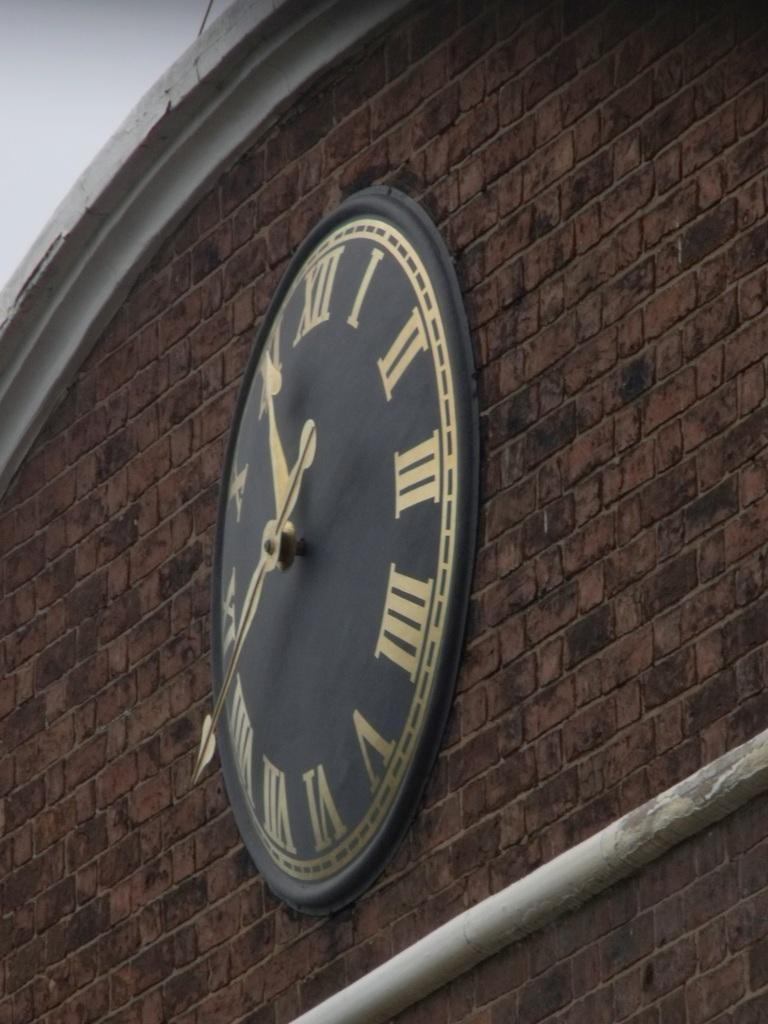<image>
Write a terse but informative summary of the picture. A clock on a brick building has gold roman numerals on it. 